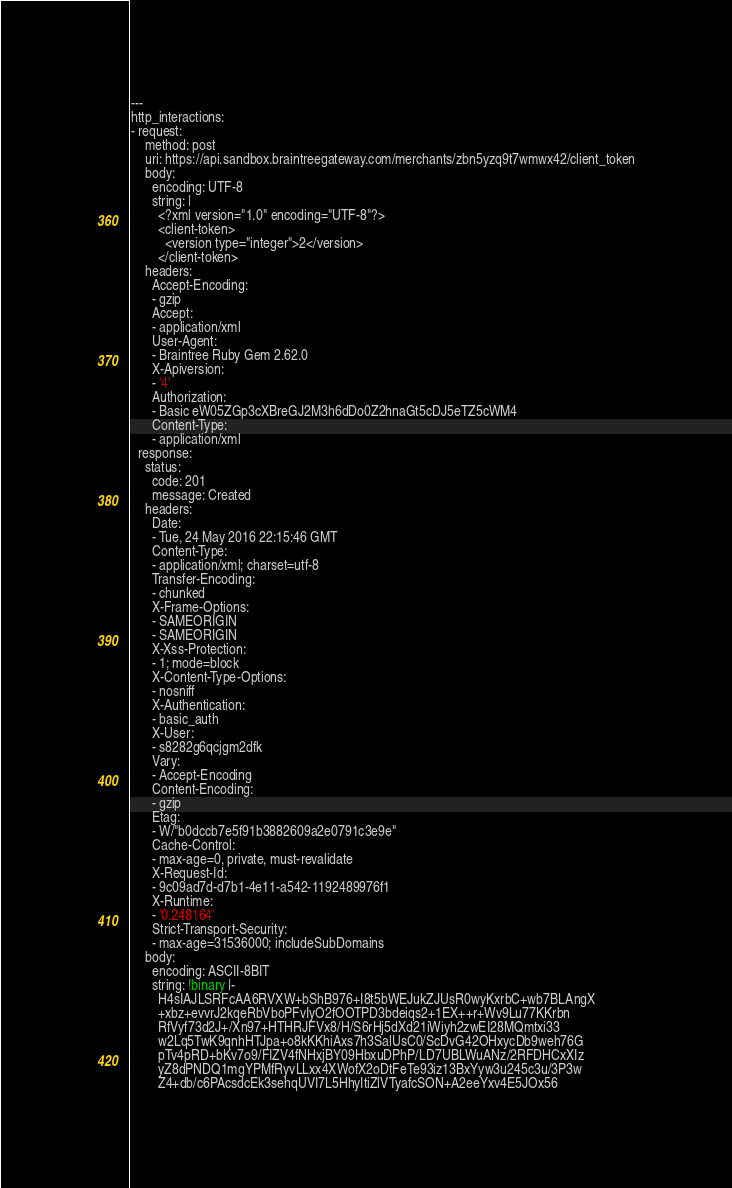Convert code to text. <code><loc_0><loc_0><loc_500><loc_500><_YAML_>---
http_interactions:
- request:
    method: post
    uri: https://api.sandbox.braintreegateway.com/merchants/zbn5yzq9t7wmwx42/client_token
    body:
      encoding: UTF-8
      string: |
        <?xml version="1.0" encoding="UTF-8"?>
        <client-token>
          <version type="integer">2</version>
        </client-token>
    headers:
      Accept-Encoding:
      - gzip
      Accept:
      - application/xml
      User-Agent:
      - Braintree Ruby Gem 2.62.0
      X-Apiversion:
      - '4'
      Authorization:
      - Basic eW05ZGp3cXBreGJ2M3h6dDo0Z2hnaGt5cDJ5eTZ5cWM4
      Content-Type:
      - application/xml
  response:
    status:
      code: 201
      message: Created
    headers:
      Date:
      - Tue, 24 May 2016 22:15:46 GMT
      Content-Type:
      - application/xml; charset=utf-8
      Transfer-Encoding:
      - chunked
      X-Frame-Options:
      - SAMEORIGIN
      - SAMEORIGIN
      X-Xss-Protection:
      - 1; mode=block
      X-Content-Type-Options:
      - nosniff
      X-Authentication:
      - basic_auth
      X-User:
      - s8282g6qcjgm2dfk
      Vary:
      - Accept-Encoding
      Content-Encoding:
      - gzip
      Etag:
      - W/"b0dccb7e5f91b3882609a2e0791c3e9e"
      Cache-Control:
      - max-age=0, private, must-revalidate
      X-Request-Id:
      - 9c09ad7d-d7b1-4e11-a542-1192489976f1
      X-Runtime:
      - '0.248164'
      Strict-Transport-Security:
      - max-age=31536000; includeSubDomains
    body:
      encoding: ASCII-8BIT
      string: !binary |-
        H4sIAJLSRFcAA6RVXW+bShB976+I8t5bWEJukZJUsR0wyKxrbC+wb7BLAngX
        +xbz+evvrJ2kqeRbVboPFvIyO2fOOTPD3bdeiqs2+1EX++r+Wv9Lu77KKrbn
        RfVyf73d2J+/Xn97+HTHRJFVx8/H/S6rHj5dXd21iWiyh2zwEI28MQmtxi33
        w2Lq5TwK9qnhHTJpa+o8kKKhiAxs7h3SalUsC0/ScDvG42OHxycDb9weh76G
        pTv4pRD+bKv7o9/FIZV4fNHxjBY09HbxuDPhP/LD7UBLWuANz/2RFDHCxXIz
        yZ8dPNDQ1mgYPMfRyvLLxx4XWofX2oDtFeTe93iz13BxYyw3u245c3u/3P3w
        Z4+db/c6PAcsdcEk3sehqUVI7L5HhyItiZlVTyafcSON+A2eeYxv4E5JOx56</code> 